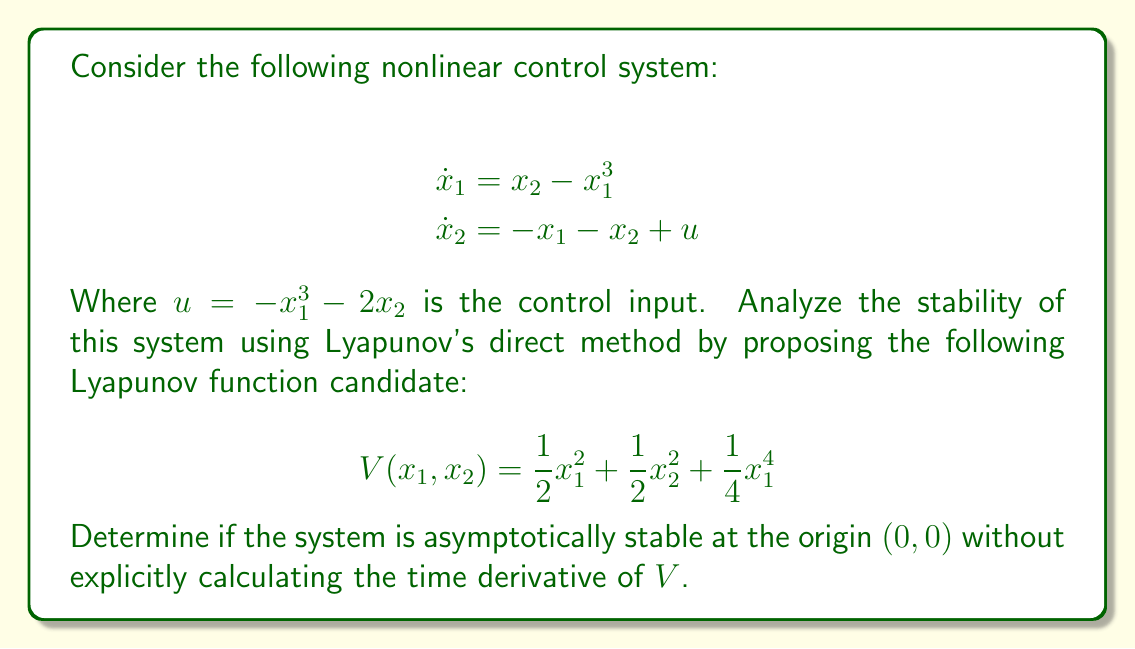Can you answer this question? To analyze the stability of the nonlinear control system using Lyapunov's direct method, we need to examine the properties of the proposed Lyapunov function candidate $V(x_1, x_2)$.

1. First, we observe that $V(x_1, x_2)$ is positive definite:
   $$V(x_1, x_2) = \frac{1}{2}x_1^2 + \frac{1}{2}x_2^2 + \frac{1}{4}x_1^4 > 0$$ for all $(x_1, x_2) \neq (0,0)$, and $V(0,0) = 0$.

2. Next, we need to examine $\dot{V}(x_1, x_2)$. However, as per the question, we are not required to explicitly calculate it. Instead, we can reason about its behavior:

   a. The time derivative of $V$ along the system trajectories would be:
      $$\dot{V} = x_1\dot{x}_1 + x_2\dot{x}_2 + x_1^3\dot{x}_1$$
   
   b. Substituting the system equations and control input:
      $$\begin{align}
      \dot{V} &= x_1(x_2 - x_1^3) + x_2(-x_1 - x_2 + u) + x_1^3(x_2 - x_1^3) \\
      &= x_1(x_2 - x_1^3) + x_2(-x_1 - x_2 - x_1^3 - 2x_2) + x_1^3(x_2 - x_1^3)
      \end{align}$$

   c. Without expanding this expression, we can observe that it contains negative quadratic terms ($-x_2^2$, $-2x_2^2$) and negative quartic terms ($-x_1^6$). These terms will dominate for large values of $x_1$ and $x_2$.

3. Based on this observation, we can conclude that $\dot{V}(x_1, x_2) < 0$ for all $(x_1, x_2) \neq (0,0)$ in some neighborhood of the origin.

4. Therefore, according to Lyapunov's direct method, the system is asymptotically stable at the origin $(0,0)$.

This analysis demonstrates the power of Lyapunov's method in determining stability without solving the differential equations or explicitly calculating time derivatives, aligning with the persona's preference for innovative approaches over rigorous data analysis.
Answer: The nonlinear control system is asymptotically stable at the origin $(0,0)$. 